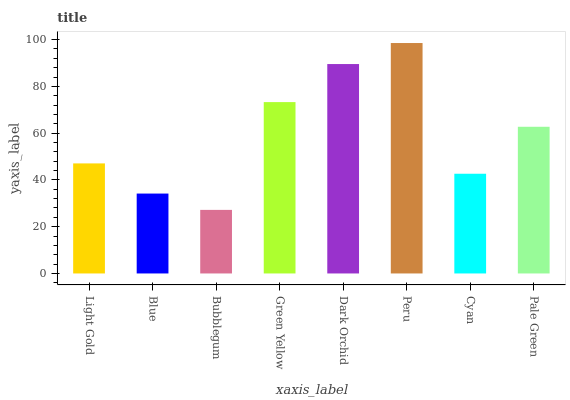Is Bubblegum the minimum?
Answer yes or no. Yes. Is Peru the maximum?
Answer yes or no. Yes. Is Blue the minimum?
Answer yes or no. No. Is Blue the maximum?
Answer yes or no. No. Is Light Gold greater than Blue?
Answer yes or no. Yes. Is Blue less than Light Gold?
Answer yes or no. Yes. Is Blue greater than Light Gold?
Answer yes or no. No. Is Light Gold less than Blue?
Answer yes or no. No. Is Pale Green the high median?
Answer yes or no. Yes. Is Light Gold the low median?
Answer yes or no. Yes. Is Bubblegum the high median?
Answer yes or no. No. Is Pale Green the low median?
Answer yes or no. No. 